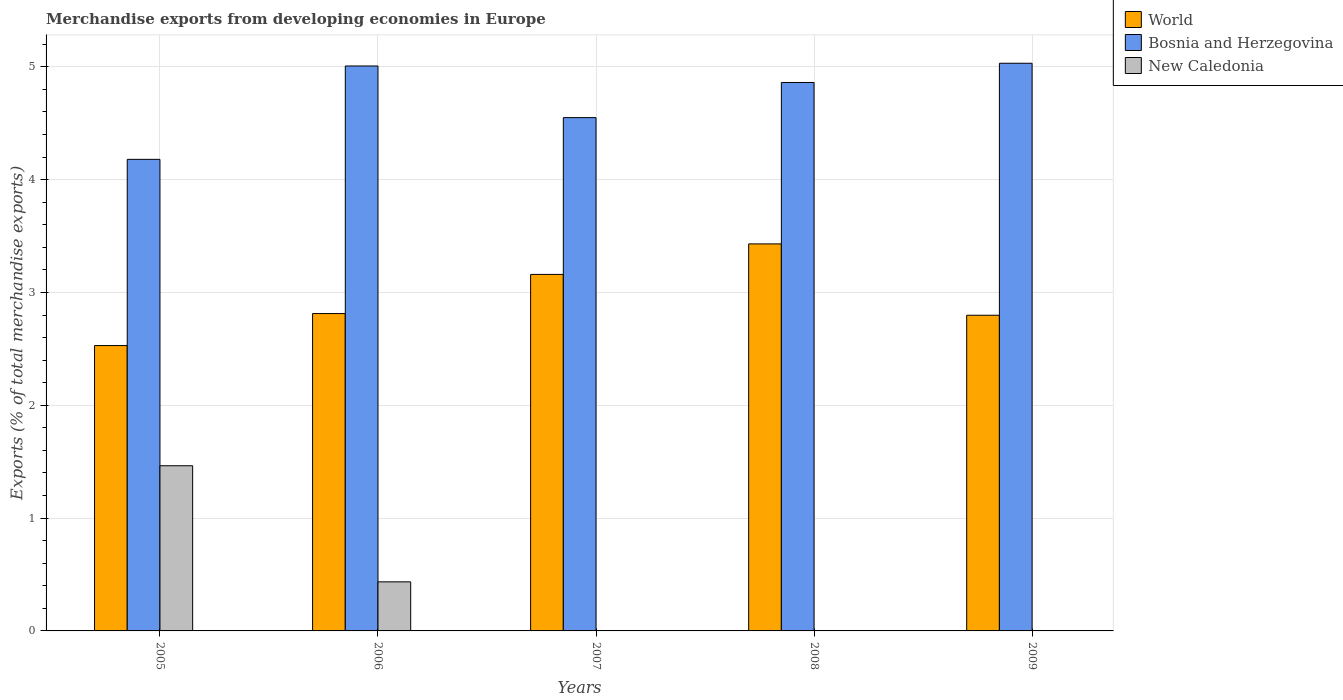How many groups of bars are there?
Offer a terse response. 5. Are the number of bars per tick equal to the number of legend labels?
Your answer should be compact. Yes. Are the number of bars on each tick of the X-axis equal?
Offer a terse response. Yes. How many bars are there on the 2nd tick from the right?
Offer a terse response. 3. What is the label of the 2nd group of bars from the left?
Offer a very short reply. 2006. In how many cases, is the number of bars for a given year not equal to the number of legend labels?
Your answer should be very brief. 0. What is the percentage of total merchandise exports in Bosnia and Herzegovina in 2007?
Provide a short and direct response. 4.55. Across all years, what is the maximum percentage of total merchandise exports in Bosnia and Herzegovina?
Offer a terse response. 5.03. Across all years, what is the minimum percentage of total merchandise exports in Bosnia and Herzegovina?
Your answer should be very brief. 4.18. In which year was the percentage of total merchandise exports in World minimum?
Provide a short and direct response. 2005. What is the total percentage of total merchandise exports in World in the graph?
Keep it short and to the point. 14.73. What is the difference between the percentage of total merchandise exports in Bosnia and Herzegovina in 2005 and that in 2006?
Your answer should be compact. -0.83. What is the difference between the percentage of total merchandise exports in Bosnia and Herzegovina in 2007 and the percentage of total merchandise exports in World in 2006?
Keep it short and to the point. 1.74. What is the average percentage of total merchandise exports in Bosnia and Herzegovina per year?
Offer a terse response. 4.73. In the year 2008, what is the difference between the percentage of total merchandise exports in Bosnia and Herzegovina and percentage of total merchandise exports in New Caledonia?
Offer a terse response. 4.86. What is the ratio of the percentage of total merchandise exports in Bosnia and Herzegovina in 2005 to that in 2007?
Provide a short and direct response. 0.92. Is the percentage of total merchandise exports in New Caledonia in 2005 less than that in 2008?
Give a very brief answer. No. What is the difference between the highest and the second highest percentage of total merchandise exports in World?
Your answer should be compact. 0.27. What is the difference between the highest and the lowest percentage of total merchandise exports in World?
Keep it short and to the point. 0.9. What does the 3rd bar from the left in 2005 represents?
Offer a very short reply. New Caledonia. Is it the case that in every year, the sum of the percentage of total merchandise exports in New Caledonia and percentage of total merchandise exports in World is greater than the percentage of total merchandise exports in Bosnia and Herzegovina?
Keep it short and to the point. No. What is the difference between two consecutive major ticks on the Y-axis?
Provide a short and direct response. 1. Does the graph contain any zero values?
Your answer should be very brief. No. Does the graph contain grids?
Ensure brevity in your answer.  Yes. Where does the legend appear in the graph?
Offer a terse response. Top right. How many legend labels are there?
Your response must be concise. 3. What is the title of the graph?
Give a very brief answer. Merchandise exports from developing economies in Europe. What is the label or title of the Y-axis?
Offer a very short reply. Exports (% of total merchandise exports). What is the Exports (% of total merchandise exports) in World in 2005?
Provide a succinct answer. 2.53. What is the Exports (% of total merchandise exports) in Bosnia and Herzegovina in 2005?
Provide a succinct answer. 4.18. What is the Exports (% of total merchandise exports) in New Caledonia in 2005?
Make the answer very short. 1.46. What is the Exports (% of total merchandise exports) of World in 2006?
Your answer should be very brief. 2.81. What is the Exports (% of total merchandise exports) of Bosnia and Herzegovina in 2006?
Your response must be concise. 5.01. What is the Exports (% of total merchandise exports) of New Caledonia in 2006?
Provide a short and direct response. 0.43. What is the Exports (% of total merchandise exports) of World in 2007?
Offer a very short reply. 3.16. What is the Exports (% of total merchandise exports) of Bosnia and Herzegovina in 2007?
Offer a very short reply. 4.55. What is the Exports (% of total merchandise exports) of New Caledonia in 2007?
Your answer should be very brief. 0. What is the Exports (% of total merchandise exports) in World in 2008?
Provide a short and direct response. 3.43. What is the Exports (% of total merchandise exports) of Bosnia and Herzegovina in 2008?
Your response must be concise. 4.86. What is the Exports (% of total merchandise exports) in New Caledonia in 2008?
Make the answer very short. 0. What is the Exports (% of total merchandise exports) in World in 2009?
Your response must be concise. 2.8. What is the Exports (% of total merchandise exports) in Bosnia and Herzegovina in 2009?
Ensure brevity in your answer.  5.03. What is the Exports (% of total merchandise exports) of New Caledonia in 2009?
Ensure brevity in your answer.  0. Across all years, what is the maximum Exports (% of total merchandise exports) in World?
Make the answer very short. 3.43. Across all years, what is the maximum Exports (% of total merchandise exports) of Bosnia and Herzegovina?
Give a very brief answer. 5.03. Across all years, what is the maximum Exports (% of total merchandise exports) in New Caledonia?
Your answer should be compact. 1.46. Across all years, what is the minimum Exports (% of total merchandise exports) in World?
Your answer should be compact. 2.53. Across all years, what is the minimum Exports (% of total merchandise exports) of Bosnia and Herzegovina?
Your answer should be compact. 4.18. Across all years, what is the minimum Exports (% of total merchandise exports) in New Caledonia?
Offer a terse response. 0. What is the total Exports (% of total merchandise exports) in World in the graph?
Make the answer very short. 14.73. What is the total Exports (% of total merchandise exports) of Bosnia and Herzegovina in the graph?
Give a very brief answer. 23.63. What is the total Exports (% of total merchandise exports) of New Caledonia in the graph?
Your answer should be very brief. 1.9. What is the difference between the Exports (% of total merchandise exports) in World in 2005 and that in 2006?
Your answer should be very brief. -0.28. What is the difference between the Exports (% of total merchandise exports) of Bosnia and Herzegovina in 2005 and that in 2006?
Give a very brief answer. -0.83. What is the difference between the Exports (% of total merchandise exports) in New Caledonia in 2005 and that in 2006?
Your answer should be compact. 1.03. What is the difference between the Exports (% of total merchandise exports) in World in 2005 and that in 2007?
Your answer should be very brief. -0.63. What is the difference between the Exports (% of total merchandise exports) of Bosnia and Herzegovina in 2005 and that in 2007?
Give a very brief answer. -0.37. What is the difference between the Exports (% of total merchandise exports) of New Caledonia in 2005 and that in 2007?
Provide a succinct answer. 1.46. What is the difference between the Exports (% of total merchandise exports) in World in 2005 and that in 2008?
Keep it short and to the point. -0.9. What is the difference between the Exports (% of total merchandise exports) in Bosnia and Herzegovina in 2005 and that in 2008?
Offer a very short reply. -0.68. What is the difference between the Exports (% of total merchandise exports) of New Caledonia in 2005 and that in 2008?
Your response must be concise. 1.46. What is the difference between the Exports (% of total merchandise exports) of World in 2005 and that in 2009?
Your answer should be very brief. -0.27. What is the difference between the Exports (% of total merchandise exports) of Bosnia and Herzegovina in 2005 and that in 2009?
Offer a very short reply. -0.85. What is the difference between the Exports (% of total merchandise exports) of New Caledonia in 2005 and that in 2009?
Provide a succinct answer. 1.46. What is the difference between the Exports (% of total merchandise exports) in World in 2006 and that in 2007?
Offer a terse response. -0.35. What is the difference between the Exports (% of total merchandise exports) in Bosnia and Herzegovina in 2006 and that in 2007?
Ensure brevity in your answer.  0.46. What is the difference between the Exports (% of total merchandise exports) in New Caledonia in 2006 and that in 2007?
Offer a terse response. 0.43. What is the difference between the Exports (% of total merchandise exports) in World in 2006 and that in 2008?
Give a very brief answer. -0.62. What is the difference between the Exports (% of total merchandise exports) of Bosnia and Herzegovina in 2006 and that in 2008?
Ensure brevity in your answer.  0.15. What is the difference between the Exports (% of total merchandise exports) in New Caledonia in 2006 and that in 2008?
Your response must be concise. 0.43. What is the difference between the Exports (% of total merchandise exports) in World in 2006 and that in 2009?
Your answer should be compact. 0.01. What is the difference between the Exports (% of total merchandise exports) in Bosnia and Herzegovina in 2006 and that in 2009?
Your response must be concise. -0.02. What is the difference between the Exports (% of total merchandise exports) of New Caledonia in 2006 and that in 2009?
Your response must be concise. 0.43. What is the difference between the Exports (% of total merchandise exports) in World in 2007 and that in 2008?
Provide a short and direct response. -0.27. What is the difference between the Exports (% of total merchandise exports) in Bosnia and Herzegovina in 2007 and that in 2008?
Your response must be concise. -0.31. What is the difference between the Exports (% of total merchandise exports) of New Caledonia in 2007 and that in 2008?
Make the answer very short. 0. What is the difference between the Exports (% of total merchandise exports) in World in 2007 and that in 2009?
Give a very brief answer. 0.36. What is the difference between the Exports (% of total merchandise exports) of Bosnia and Herzegovina in 2007 and that in 2009?
Your answer should be compact. -0.48. What is the difference between the Exports (% of total merchandise exports) of New Caledonia in 2007 and that in 2009?
Your response must be concise. 0. What is the difference between the Exports (% of total merchandise exports) in World in 2008 and that in 2009?
Your answer should be very brief. 0.63. What is the difference between the Exports (% of total merchandise exports) in Bosnia and Herzegovina in 2008 and that in 2009?
Make the answer very short. -0.17. What is the difference between the Exports (% of total merchandise exports) of New Caledonia in 2008 and that in 2009?
Provide a short and direct response. -0. What is the difference between the Exports (% of total merchandise exports) of World in 2005 and the Exports (% of total merchandise exports) of Bosnia and Herzegovina in 2006?
Provide a succinct answer. -2.48. What is the difference between the Exports (% of total merchandise exports) of World in 2005 and the Exports (% of total merchandise exports) of New Caledonia in 2006?
Your response must be concise. 2.09. What is the difference between the Exports (% of total merchandise exports) of Bosnia and Herzegovina in 2005 and the Exports (% of total merchandise exports) of New Caledonia in 2006?
Give a very brief answer. 3.75. What is the difference between the Exports (% of total merchandise exports) of World in 2005 and the Exports (% of total merchandise exports) of Bosnia and Herzegovina in 2007?
Your answer should be compact. -2.02. What is the difference between the Exports (% of total merchandise exports) in World in 2005 and the Exports (% of total merchandise exports) in New Caledonia in 2007?
Make the answer very short. 2.53. What is the difference between the Exports (% of total merchandise exports) in Bosnia and Herzegovina in 2005 and the Exports (% of total merchandise exports) in New Caledonia in 2007?
Provide a short and direct response. 4.18. What is the difference between the Exports (% of total merchandise exports) in World in 2005 and the Exports (% of total merchandise exports) in Bosnia and Herzegovina in 2008?
Provide a short and direct response. -2.33. What is the difference between the Exports (% of total merchandise exports) in World in 2005 and the Exports (% of total merchandise exports) in New Caledonia in 2008?
Make the answer very short. 2.53. What is the difference between the Exports (% of total merchandise exports) of Bosnia and Herzegovina in 2005 and the Exports (% of total merchandise exports) of New Caledonia in 2008?
Your answer should be very brief. 4.18. What is the difference between the Exports (% of total merchandise exports) in World in 2005 and the Exports (% of total merchandise exports) in Bosnia and Herzegovina in 2009?
Give a very brief answer. -2.5. What is the difference between the Exports (% of total merchandise exports) in World in 2005 and the Exports (% of total merchandise exports) in New Caledonia in 2009?
Provide a short and direct response. 2.53. What is the difference between the Exports (% of total merchandise exports) of Bosnia and Herzegovina in 2005 and the Exports (% of total merchandise exports) of New Caledonia in 2009?
Keep it short and to the point. 4.18. What is the difference between the Exports (% of total merchandise exports) of World in 2006 and the Exports (% of total merchandise exports) of Bosnia and Herzegovina in 2007?
Give a very brief answer. -1.74. What is the difference between the Exports (% of total merchandise exports) in World in 2006 and the Exports (% of total merchandise exports) in New Caledonia in 2007?
Your answer should be very brief. 2.81. What is the difference between the Exports (% of total merchandise exports) of Bosnia and Herzegovina in 2006 and the Exports (% of total merchandise exports) of New Caledonia in 2007?
Provide a succinct answer. 5.01. What is the difference between the Exports (% of total merchandise exports) in World in 2006 and the Exports (% of total merchandise exports) in Bosnia and Herzegovina in 2008?
Provide a succinct answer. -2.05. What is the difference between the Exports (% of total merchandise exports) in World in 2006 and the Exports (% of total merchandise exports) in New Caledonia in 2008?
Provide a succinct answer. 2.81. What is the difference between the Exports (% of total merchandise exports) of Bosnia and Herzegovina in 2006 and the Exports (% of total merchandise exports) of New Caledonia in 2008?
Provide a succinct answer. 5.01. What is the difference between the Exports (% of total merchandise exports) in World in 2006 and the Exports (% of total merchandise exports) in Bosnia and Herzegovina in 2009?
Offer a very short reply. -2.22. What is the difference between the Exports (% of total merchandise exports) in World in 2006 and the Exports (% of total merchandise exports) in New Caledonia in 2009?
Provide a succinct answer. 2.81. What is the difference between the Exports (% of total merchandise exports) of Bosnia and Herzegovina in 2006 and the Exports (% of total merchandise exports) of New Caledonia in 2009?
Your answer should be compact. 5.01. What is the difference between the Exports (% of total merchandise exports) in World in 2007 and the Exports (% of total merchandise exports) in Bosnia and Herzegovina in 2008?
Provide a succinct answer. -1.7. What is the difference between the Exports (% of total merchandise exports) in World in 2007 and the Exports (% of total merchandise exports) in New Caledonia in 2008?
Provide a short and direct response. 3.16. What is the difference between the Exports (% of total merchandise exports) in Bosnia and Herzegovina in 2007 and the Exports (% of total merchandise exports) in New Caledonia in 2008?
Make the answer very short. 4.55. What is the difference between the Exports (% of total merchandise exports) of World in 2007 and the Exports (% of total merchandise exports) of Bosnia and Herzegovina in 2009?
Your answer should be very brief. -1.87. What is the difference between the Exports (% of total merchandise exports) in World in 2007 and the Exports (% of total merchandise exports) in New Caledonia in 2009?
Offer a terse response. 3.16. What is the difference between the Exports (% of total merchandise exports) of Bosnia and Herzegovina in 2007 and the Exports (% of total merchandise exports) of New Caledonia in 2009?
Offer a very short reply. 4.55. What is the difference between the Exports (% of total merchandise exports) in World in 2008 and the Exports (% of total merchandise exports) in Bosnia and Herzegovina in 2009?
Your answer should be compact. -1.6. What is the difference between the Exports (% of total merchandise exports) of World in 2008 and the Exports (% of total merchandise exports) of New Caledonia in 2009?
Give a very brief answer. 3.43. What is the difference between the Exports (% of total merchandise exports) in Bosnia and Herzegovina in 2008 and the Exports (% of total merchandise exports) in New Caledonia in 2009?
Ensure brevity in your answer.  4.86. What is the average Exports (% of total merchandise exports) of World per year?
Provide a succinct answer. 2.95. What is the average Exports (% of total merchandise exports) in Bosnia and Herzegovina per year?
Keep it short and to the point. 4.73. What is the average Exports (% of total merchandise exports) in New Caledonia per year?
Keep it short and to the point. 0.38. In the year 2005, what is the difference between the Exports (% of total merchandise exports) of World and Exports (% of total merchandise exports) of Bosnia and Herzegovina?
Your answer should be compact. -1.65. In the year 2005, what is the difference between the Exports (% of total merchandise exports) in World and Exports (% of total merchandise exports) in New Caledonia?
Provide a succinct answer. 1.07. In the year 2005, what is the difference between the Exports (% of total merchandise exports) in Bosnia and Herzegovina and Exports (% of total merchandise exports) in New Caledonia?
Make the answer very short. 2.72. In the year 2006, what is the difference between the Exports (% of total merchandise exports) of World and Exports (% of total merchandise exports) of Bosnia and Herzegovina?
Offer a terse response. -2.19. In the year 2006, what is the difference between the Exports (% of total merchandise exports) of World and Exports (% of total merchandise exports) of New Caledonia?
Your answer should be compact. 2.38. In the year 2006, what is the difference between the Exports (% of total merchandise exports) of Bosnia and Herzegovina and Exports (% of total merchandise exports) of New Caledonia?
Keep it short and to the point. 4.57. In the year 2007, what is the difference between the Exports (% of total merchandise exports) of World and Exports (% of total merchandise exports) of Bosnia and Herzegovina?
Your response must be concise. -1.39. In the year 2007, what is the difference between the Exports (% of total merchandise exports) in World and Exports (% of total merchandise exports) in New Caledonia?
Give a very brief answer. 3.16. In the year 2007, what is the difference between the Exports (% of total merchandise exports) of Bosnia and Herzegovina and Exports (% of total merchandise exports) of New Caledonia?
Give a very brief answer. 4.55. In the year 2008, what is the difference between the Exports (% of total merchandise exports) of World and Exports (% of total merchandise exports) of Bosnia and Herzegovina?
Provide a short and direct response. -1.43. In the year 2008, what is the difference between the Exports (% of total merchandise exports) of World and Exports (% of total merchandise exports) of New Caledonia?
Ensure brevity in your answer.  3.43. In the year 2008, what is the difference between the Exports (% of total merchandise exports) of Bosnia and Herzegovina and Exports (% of total merchandise exports) of New Caledonia?
Offer a terse response. 4.86. In the year 2009, what is the difference between the Exports (% of total merchandise exports) of World and Exports (% of total merchandise exports) of Bosnia and Herzegovina?
Your answer should be very brief. -2.23. In the year 2009, what is the difference between the Exports (% of total merchandise exports) of World and Exports (% of total merchandise exports) of New Caledonia?
Give a very brief answer. 2.8. In the year 2009, what is the difference between the Exports (% of total merchandise exports) in Bosnia and Herzegovina and Exports (% of total merchandise exports) in New Caledonia?
Your answer should be very brief. 5.03. What is the ratio of the Exports (% of total merchandise exports) in World in 2005 to that in 2006?
Make the answer very short. 0.9. What is the ratio of the Exports (% of total merchandise exports) of Bosnia and Herzegovina in 2005 to that in 2006?
Offer a terse response. 0.83. What is the ratio of the Exports (% of total merchandise exports) of New Caledonia in 2005 to that in 2006?
Offer a terse response. 3.37. What is the ratio of the Exports (% of total merchandise exports) of World in 2005 to that in 2007?
Offer a very short reply. 0.8. What is the ratio of the Exports (% of total merchandise exports) of Bosnia and Herzegovina in 2005 to that in 2007?
Your response must be concise. 0.92. What is the ratio of the Exports (% of total merchandise exports) in New Caledonia in 2005 to that in 2007?
Your response must be concise. 768.76. What is the ratio of the Exports (% of total merchandise exports) of World in 2005 to that in 2008?
Your answer should be compact. 0.74. What is the ratio of the Exports (% of total merchandise exports) in Bosnia and Herzegovina in 2005 to that in 2008?
Ensure brevity in your answer.  0.86. What is the ratio of the Exports (% of total merchandise exports) of New Caledonia in 2005 to that in 2008?
Provide a short and direct response. 2441.59. What is the ratio of the Exports (% of total merchandise exports) of World in 2005 to that in 2009?
Make the answer very short. 0.9. What is the ratio of the Exports (% of total merchandise exports) in Bosnia and Herzegovina in 2005 to that in 2009?
Your response must be concise. 0.83. What is the ratio of the Exports (% of total merchandise exports) in New Caledonia in 2005 to that in 2009?
Ensure brevity in your answer.  1789.38. What is the ratio of the Exports (% of total merchandise exports) in World in 2006 to that in 2007?
Keep it short and to the point. 0.89. What is the ratio of the Exports (% of total merchandise exports) in Bosnia and Herzegovina in 2006 to that in 2007?
Your answer should be compact. 1.1. What is the ratio of the Exports (% of total merchandise exports) of New Caledonia in 2006 to that in 2007?
Offer a very short reply. 228.37. What is the ratio of the Exports (% of total merchandise exports) in World in 2006 to that in 2008?
Offer a terse response. 0.82. What is the ratio of the Exports (% of total merchandise exports) in Bosnia and Herzegovina in 2006 to that in 2008?
Ensure brevity in your answer.  1.03. What is the ratio of the Exports (% of total merchandise exports) of New Caledonia in 2006 to that in 2008?
Give a very brief answer. 725.3. What is the ratio of the Exports (% of total merchandise exports) of New Caledonia in 2006 to that in 2009?
Offer a very short reply. 531.55. What is the ratio of the Exports (% of total merchandise exports) of World in 2007 to that in 2008?
Offer a terse response. 0.92. What is the ratio of the Exports (% of total merchandise exports) in Bosnia and Herzegovina in 2007 to that in 2008?
Your response must be concise. 0.94. What is the ratio of the Exports (% of total merchandise exports) in New Caledonia in 2007 to that in 2008?
Provide a short and direct response. 3.18. What is the ratio of the Exports (% of total merchandise exports) of World in 2007 to that in 2009?
Provide a succinct answer. 1.13. What is the ratio of the Exports (% of total merchandise exports) of Bosnia and Herzegovina in 2007 to that in 2009?
Give a very brief answer. 0.9. What is the ratio of the Exports (% of total merchandise exports) of New Caledonia in 2007 to that in 2009?
Provide a short and direct response. 2.33. What is the ratio of the Exports (% of total merchandise exports) of World in 2008 to that in 2009?
Your answer should be very brief. 1.23. What is the ratio of the Exports (% of total merchandise exports) in Bosnia and Herzegovina in 2008 to that in 2009?
Your answer should be compact. 0.97. What is the ratio of the Exports (% of total merchandise exports) of New Caledonia in 2008 to that in 2009?
Ensure brevity in your answer.  0.73. What is the difference between the highest and the second highest Exports (% of total merchandise exports) in World?
Your response must be concise. 0.27. What is the difference between the highest and the second highest Exports (% of total merchandise exports) in Bosnia and Herzegovina?
Ensure brevity in your answer.  0.02. What is the difference between the highest and the second highest Exports (% of total merchandise exports) in New Caledonia?
Offer a very short reply. 1.03. What is the difference between the highest and the lowest Exports (% of total merchandise exports) of World?
Ensure brevity in your answer.  0.9. What is the difference between the highest and the lowest Exports (% of total merchandise exports) of Bosnia and Herzegovina?
Give a very brief answer. 0.85. What is the difference between the highest and the lowest Exports (% of total merchandise exports) in New Caledonia?
Your answer should be compact. 1.46. 